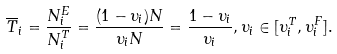<formula> <loc_0><loc_0><loc_500><loc_500>\overline { T } _ { i } = \frac { N ^ { E } _ { i } } { N ^ { T } _ { i } } = \frac { ( 1 - \upsilon _ { i } ) N } { \upsilon _ { i } N } = \frac { 1 - \upsilon _ { i } } { \upsilon _ { i } } , \upsilon _ { i } \in [ \upsilon ^ { T } _ { i } , \upsilon ^ { F } _ { i } ] .</formula> 